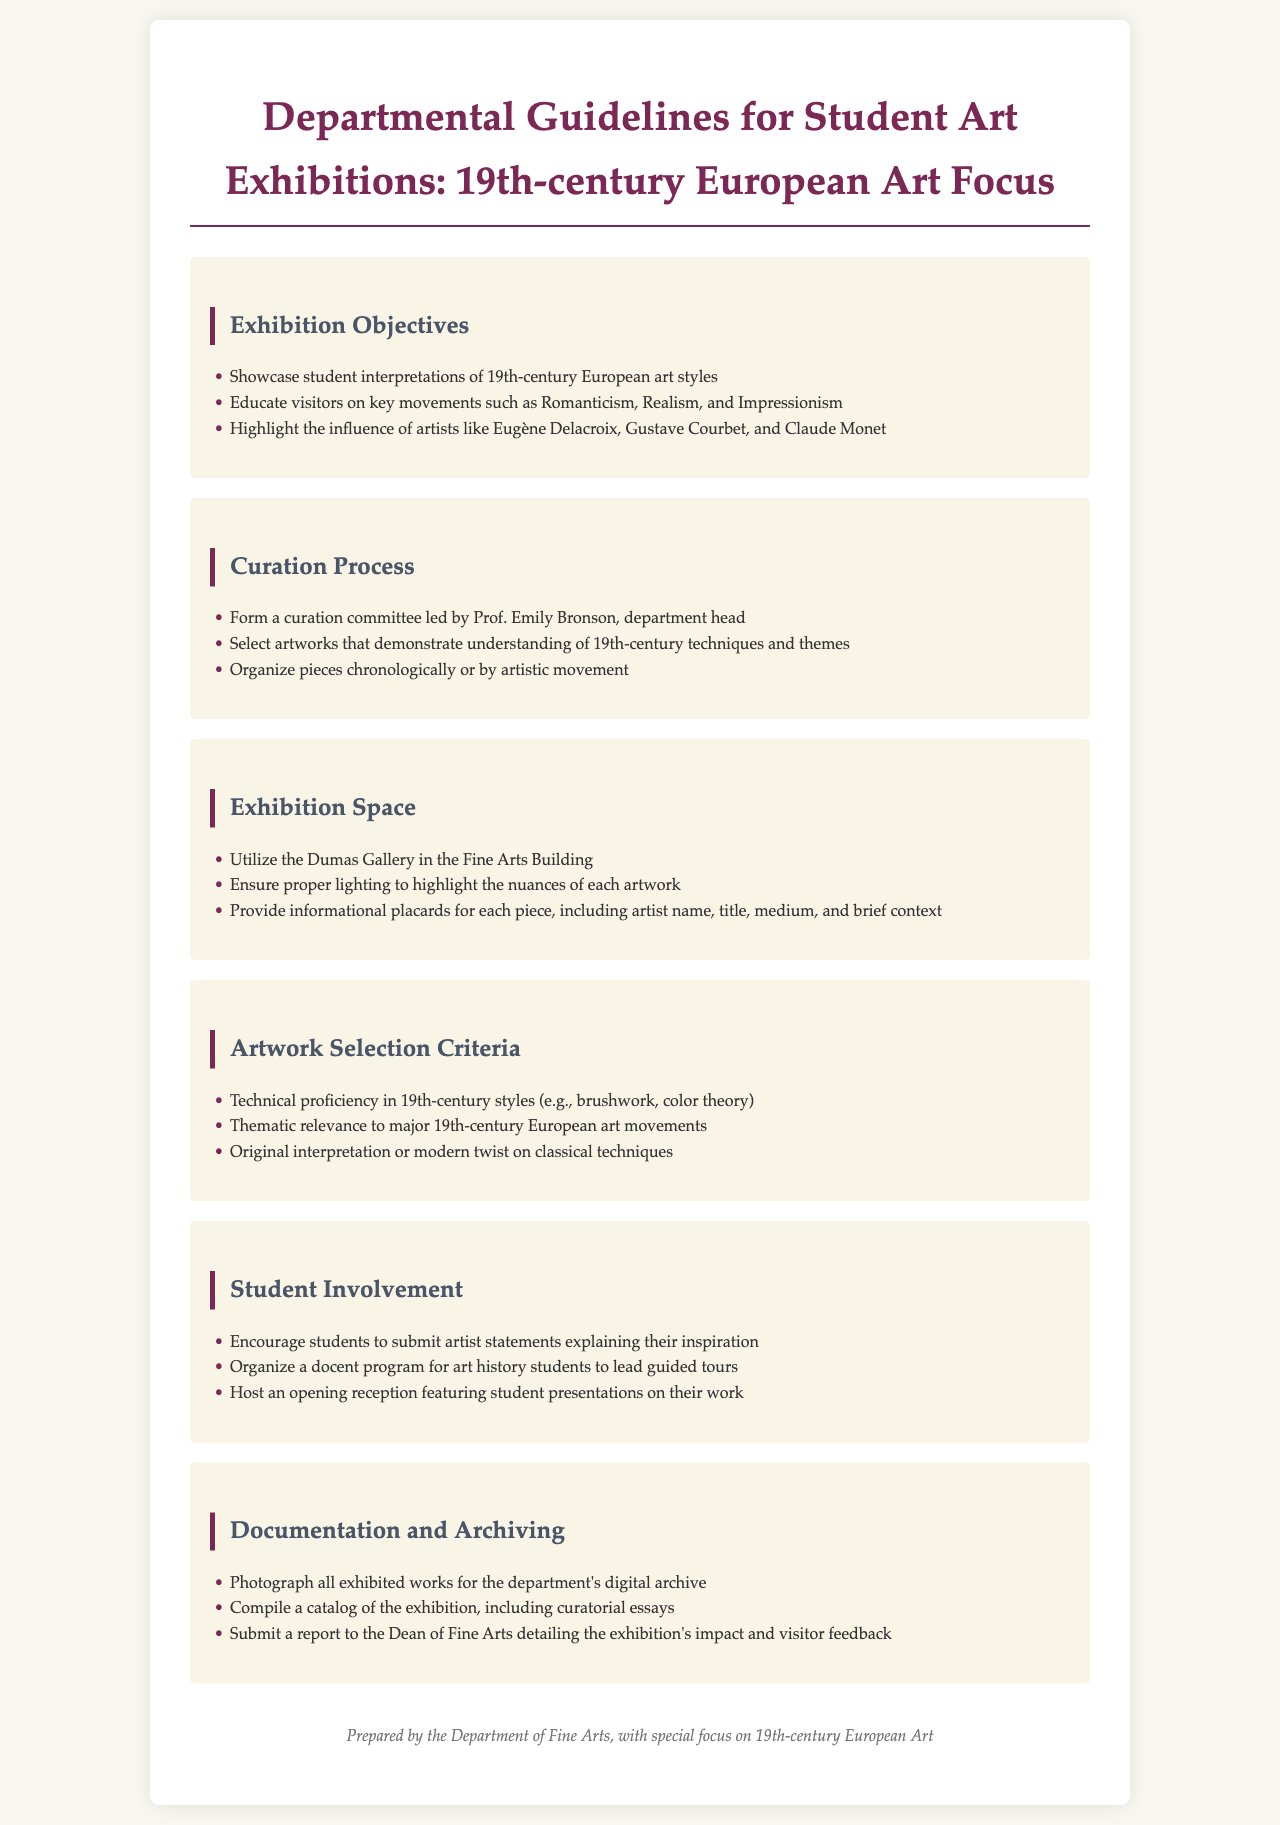What is the main focus of the exhibition? The main focus of the exhibition is to showcase student interpretations of 19th-century European art styles.
Answer: 19th-century European art styles Who leads the curation committee? The curation committee is led by Prof. Emily Bronson, the department head.
Answer: Prof. Emily Bronson What are examples of key movements highlighted in the exhibition? The exhibition educates visitors on key movements such as Romanticism, Realism, and Impressionism.
Answer: Romanticism, Realism, Impressionism Where will the exhibition take place? The exhibition will be held in the Dumas Gallery in the Fine Arts Building.
Answer: Dumas Gallery What should students submit alongside their artworks? Students are encouraged to submit artist statements explaining their inspiration.
Answer: Artist statements What is one of the documentation requirements after the exhibition? One of the documentation requirements is to compile a catalog of the exhibition, including curatorial essays.
Answer: Compile a catalog How will the artworks be organized in the exhibition? The artworks can be organized chronologically or by artistic movement.
Answer: Chronologically or by artistic movement What type of feedback will be reported to the Dean of Fine Arts? A report detailing the exhibition's impact and visitor feedback will be submitted to the Dean of Fine Arts.
Answer: Exhibition's impact and visitor feedback 